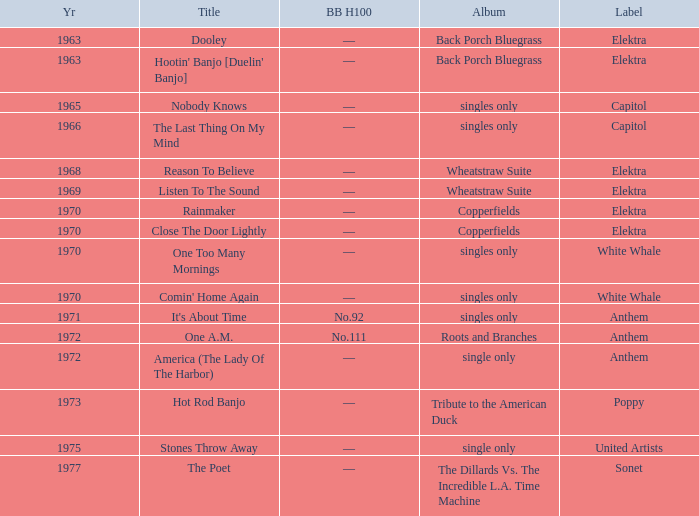What is the total years for roots and branches? 1972.0. 